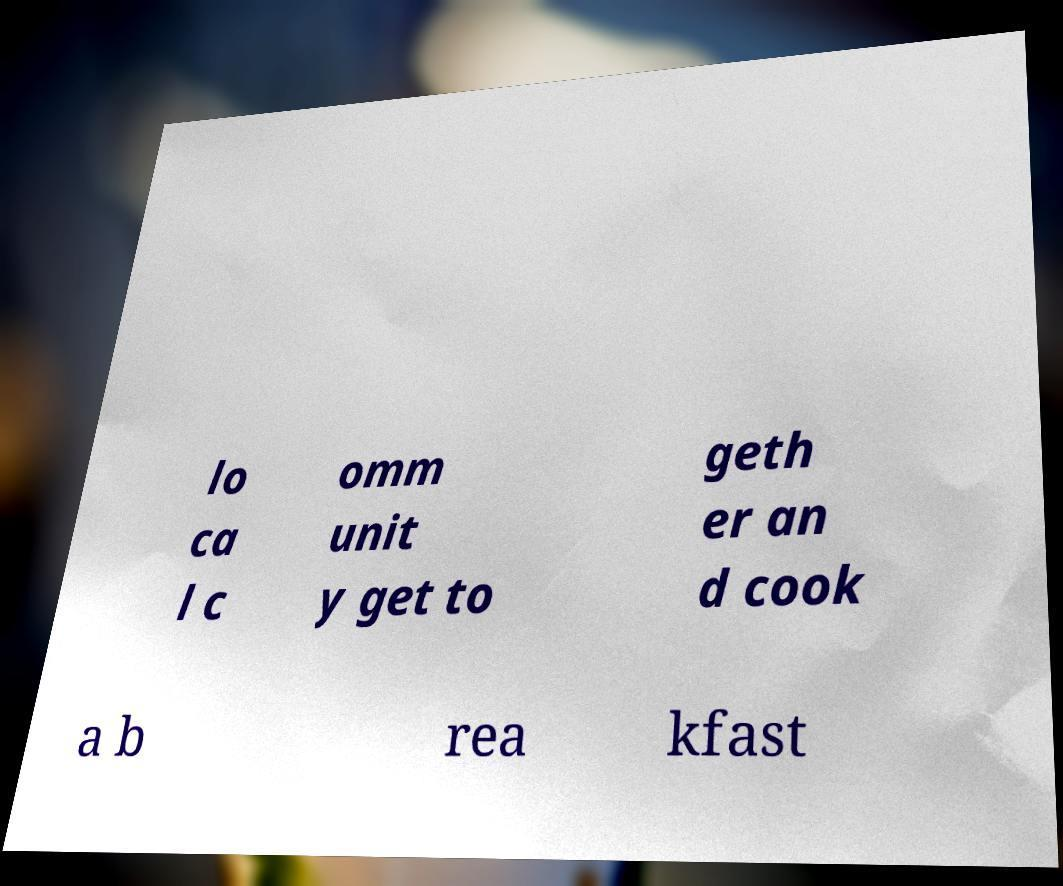Can you accurately transcribe the text from the provided image for me? lo ca l c omm unit y get to geth er an d cook a b rea kfast 